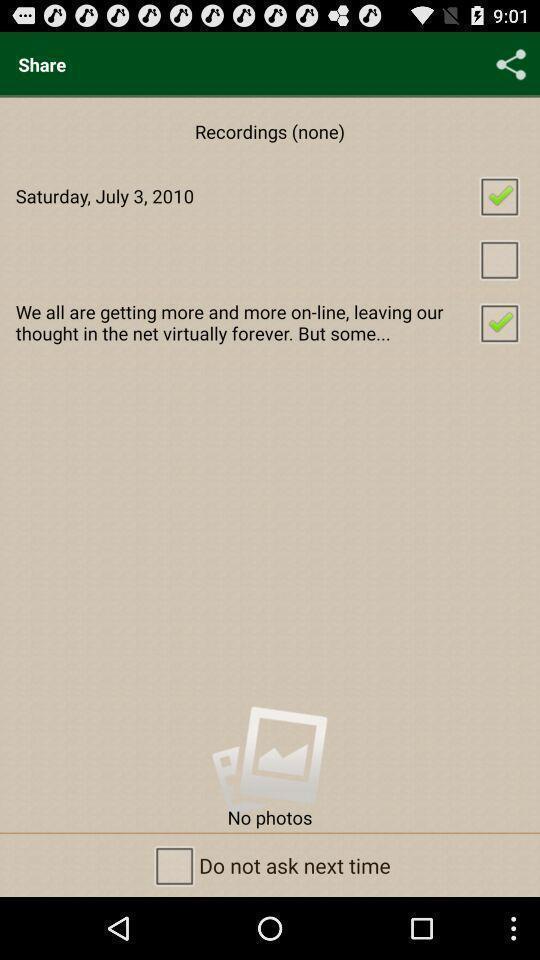Tell me what you see in this picture. Window displaying an app to protect data. 